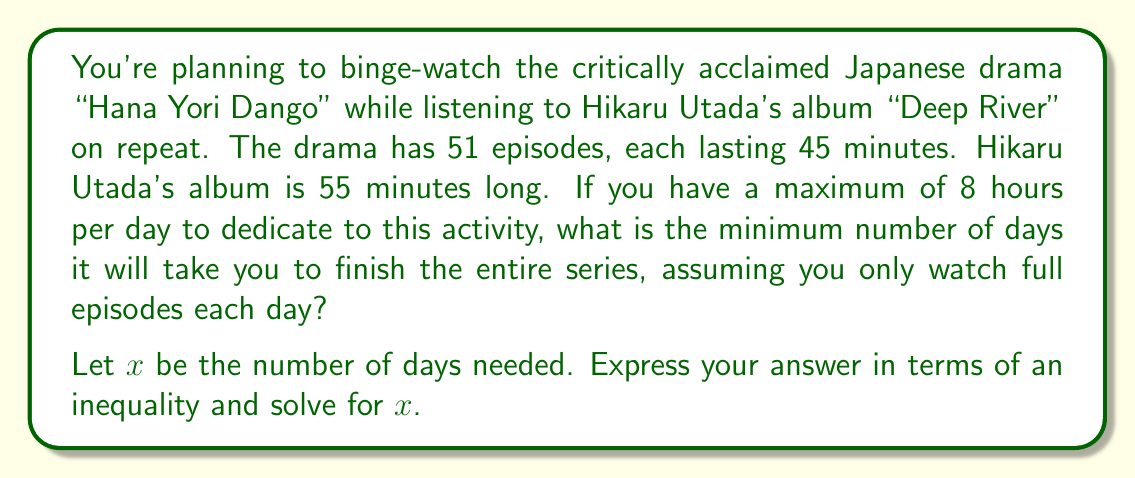Help me with this question. Let's approach this step-by-step:

1) First, calculate the total viewing time for the series:
   $51 \text{ episodes} \times 45 \text{ minutes} = 2295 \text{ minutes}$

2) Convert this to hours:
   $2295 \text{ minutes} = 38.25 \text{ hours}$

3) We know you can watch for a maximum of 8 hours per day. This gives us the inequality:
   $8x \geq 38.25$, where $x$ is the number of days

4) Solve the inequality:
   $$\begin{align}
   8x &\geq 38.25 \\
   x &\geq 38.25 / 8 \\
   x &\geq 4.78125
   \end{align}$$

5) Since we can only watch full episodes each day, we need to round up to the nearest whole number:
   $x \geq 5$

6) Therefore, the minimum number of days needed is 5.

Note: The Hikaru Utada album length doesn't affect the calculation as it's shorter than the total viewing time and can be looped.
Answer: $x \geq 5$ days 